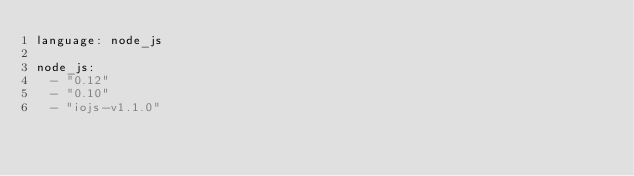Convert code to text. <code><loc_0><loc_0><loc_500><loc_500><_YAML_>language: node_js

node_js:
  - "0.12"
  - "0.10"
  - "iojs-v1.1.0"
</code> 